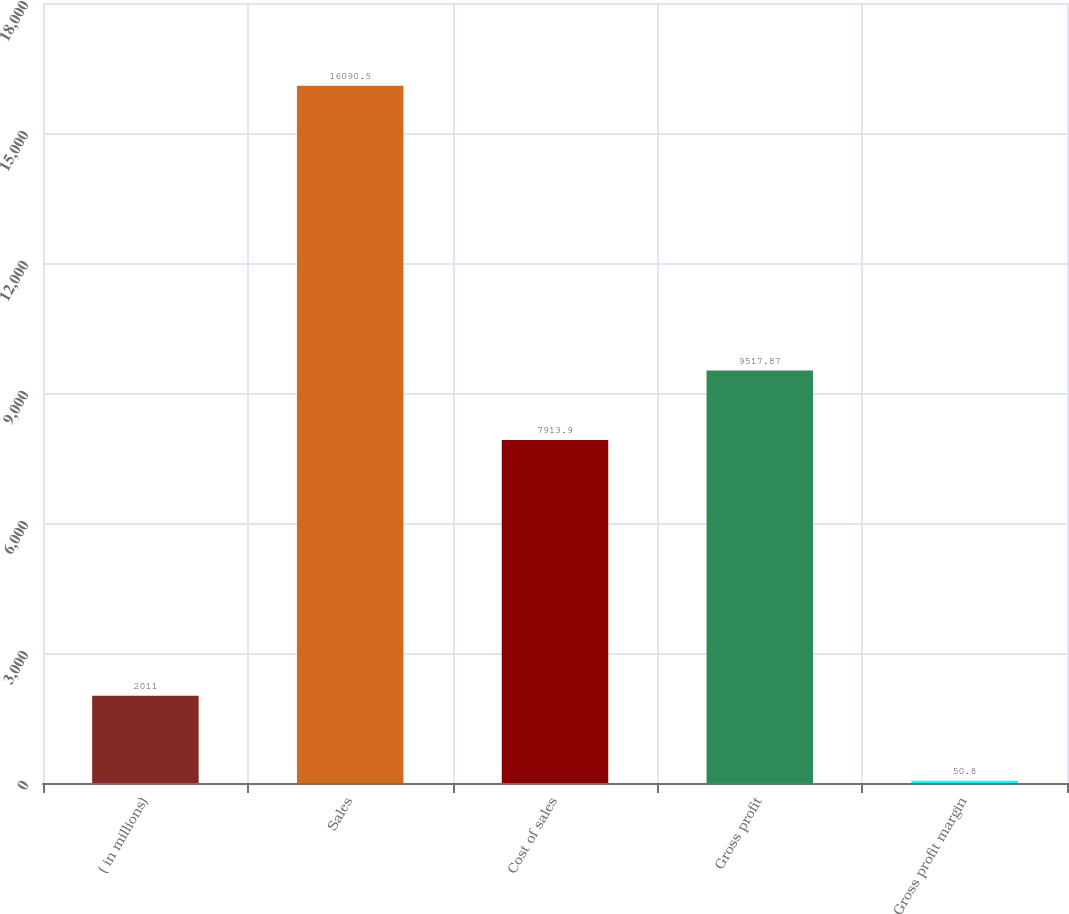Convert chart. <chart><loc_0><loc_0><loc_500><loc_500><bar_chart><fcel>( in millions)<fcel>Sales<fcel>Cost of sales<fcel>Gross profit<fcel>Gross profit margin<nl><fcel>2011<fcel>16090.5<fcel>7913.9<fcel>9517.87<fcel>50.8<nl></chart> 